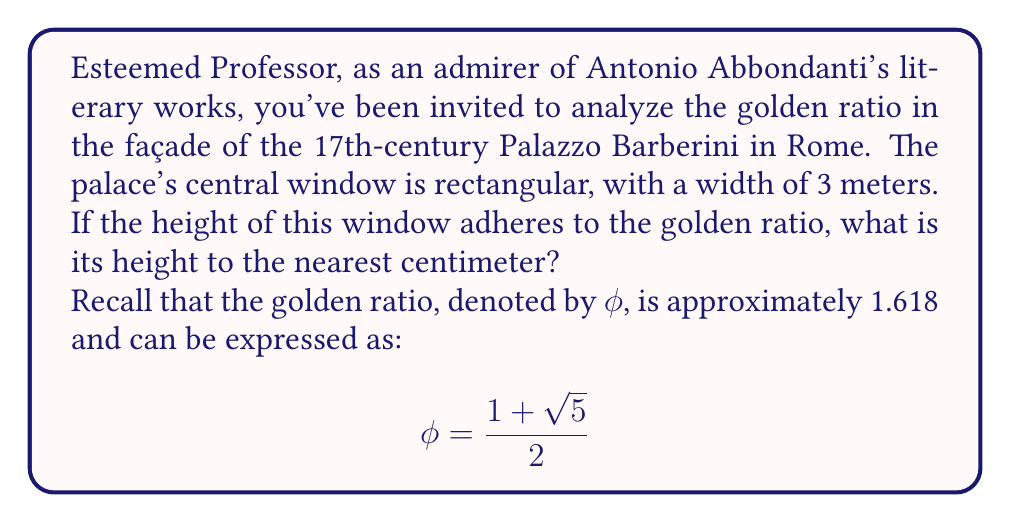Solve this math problem. To solve this problem, we shall follow these steps:

1) The golden ratio $\phi$ is defined as the ratio of the longer side to the shorter side of a rectangle. In this case, the height (h) is the longer side, and the width (w) is the shorter side. Thus:

   $$\frac{h}{w} = \phi$$

2) We know that $w = 3$ meters. Let's substitute this and the value of $\phi$:

   $$\frac{h}{3} = \frac{1 + \sqrt{5}}{2}$$

3) To find h, we multiply both sides by 3:

   $$h = 3 \cdot \frac{1 + \sqrt{5}}{2}$$

4) Let's simplify this expression:

   $$h = \frac{3(1 + \sqrt{5})}{2} = \frac{3 + 3\sqrt{5}}{2}$$

5) Now, let's calculate this value:
   
   $$h = \frac{3 + 3\sqrt{5}}{2} \approx 4.8541$$

6) Rounding to the nearest centimeter (0.01 m), we get 4.85 meters.

This analysis reveals how 17th-century Italian architects, much like the literary figures of the time, sought to incorporate classical ideals of beauty and proportion into their work.
Answer: The height of the window is approximately 4.85 meters. 